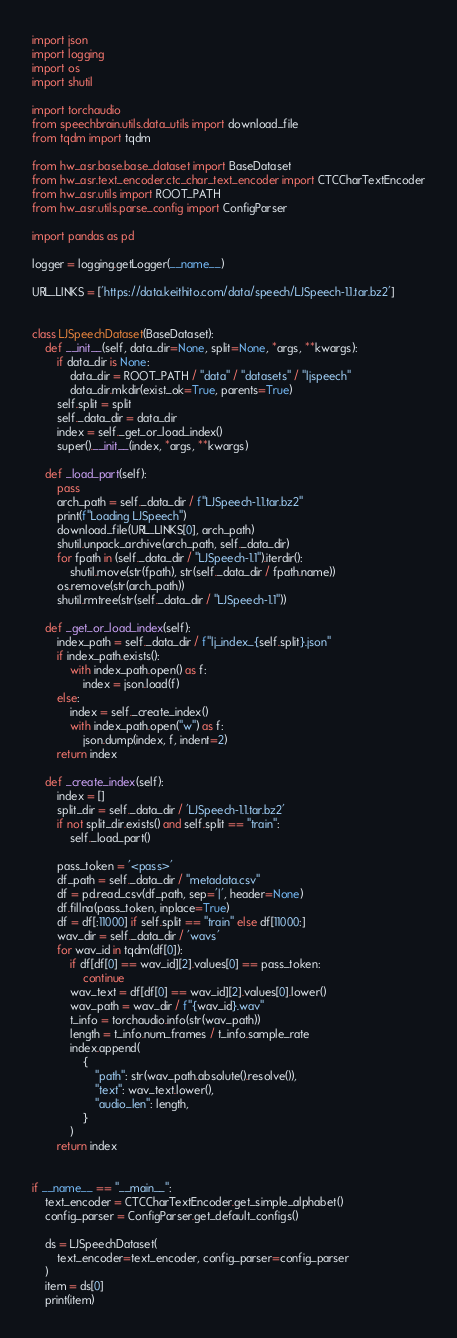<code> <loc_0><loc_0><loc_500><loc_500><_Python_>import json
import logging
import os
import shutil

import torchaudio
from speechbrain.utils.data_utils import download_file
from tqdm import tqdm

from hw_asr.base.base_dataset import BaseDataset
from hw_asr.text_encoder.ctc_char_text_encoder import CTCCharTextEncoder
from hw_asr.utils import ROOT_PATH
from hw_asr.utils.parse_config import ConfigParser

import pandas as pd

logger = logging.getLogger(__name__)

URL_LINKS = ['https://data.keithito.com/data/speech/LJSpeech-1.1.tar.bz2']


class LJSpeechDataset(BaseDataset):
    def __init__(self, data_dir=None, split=None, *args, **kwargs):
        if data_dir is None:
            data_dir = ROOT_PATH / "data" / "datasets" / "ljspeech"
            data_dir.mkdir(exist_ok=True, parents=True)
        self.split = split
        self._data_dir = data_dir
        index = self._get_or_load_index()
        super().__init__(index, *args, **kwargs)

    def _load_part(self):
        pass
        arch_path = self._data_dir / f"LJSpeech-1.1.tar.bz2"
        print(f"Loading LJSpeech")
        download_file(URL_LINKS[0], arch_path)
        shutil.unpack_archive(arch_path, self._data_dir)
        for fpath in (self._data_dir / "LJSpeech-1.1").iterdir():
            shutil.move(str(fpath), str(self._data_dir / fpath.name))
        os.remove(str(arch_path))
        shutil.rmtree(str(self._data_dir / "LJSpeech-1.1"))

    def _get_or_load_index(self):
        index_path = self._data_dir / f"lj_index_{self.split}.json"
        if index_path.exists():
            with index_path.open() as f:
                index = json.load(f)
        else:
            index = self._create_index()
            with index_path.open("w") as f:
                json.dump(index, f, indent=2)
        return index

    def _create_index(self):
        index = []
        split_dir = self._data_dir / 'LJSpeech-1.1.tar.bz2'
        if not split_dir.exists() and self.split == "train":
            self._load_part()

        pass_token = '<pass>'
        df_path = self._data_dir / "metadata.csv"
        df = pd.read_csv(df_path, sep='|', header=None)
        df.fillna(pass_token, inplace=True)
        df = df[:11000] if self.split == "train" else df[11000:]
        wav_dir = self._data_dir / 'wavs'
        for wav_id in tqdm(df[0]):
            if df[df[0] == wav_id][2].values[0] == pass_token:
                continue
            wav_text = df[df[0] == wav_id][2].values[0].lower()
            wav_path = wav_dir / f"{wav_id}.wav"
            t_info = torchaudio.info(str(wav_path))
            length = t_info.num_frames / t_info.sample_rate
            index.append(
                {
                    "path": str(wav_path.absolute().resolve()),
                    "text": wav_text.lower(),
                    "audio_len": length,
                }
            )
        return index


if __name__ == "__main__":
    text_encoder = CTCCharTextEncoder.get_simple_alphabet()
    config_parser = ConfigParser.get_default_configs()

    ds = LJSpeechDataset(
        text_encoder=text_encoder, config_parser=config_parser
    )
    item = ds[0]
    print(item)
</code> 